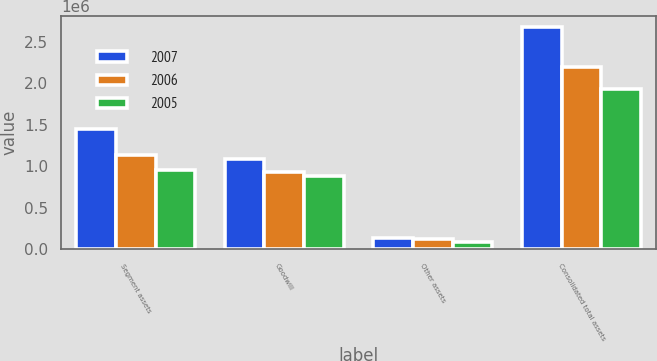<chart> <loc_0><loc_0><loc_500><loc_500><stacked_bar_chart><ecel><fcel>Segment assets<fcel>Goodwill<fcel>Other assets<fcel>Consolidated total assets<nl><fcel>2007<fcel>1.45262e+06<fcel>1.09183e+06<fcel>131283<fcel>2.67573e+06<nl><fcel>2006<fcel>1.13987e+06<fcel>926242<fcel>129282<fcel>2.1954e+06<nl><fcel>2005<fcel>957559<fcel>886720<fcel>88261<fcel>1.93254e+06<nl></chart> 